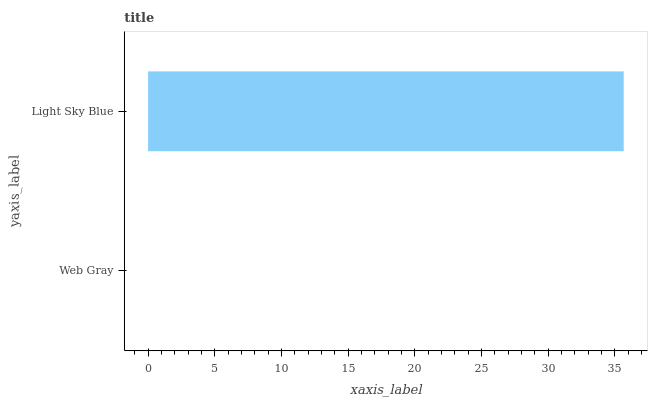Is Web Gray the minimum?
Answer yes or no. Yes. Is Light Sky Blue the maximum?
Answer yes or no. Yes. Is Light Sky Blue the minimum?
Answer yes or no. No. Is Light Sky Blue greater than Web Gray?
Answer yes or no. Yes. Is Web Gray less than Light Sky Blue?
Answer yes or no. Yes. Is Web Gray greater than Light Sky Blue?
Answer yes or no. No. Is Light Sky Blue less than Web Gray?
Answer yes or no. No. Is Light Sky Blue the high median?
Answer yes or no. Yes. Is Web Gray the low median?
Answer yes or no. Yes. Is Web Gray the high median?
Answer yes or no. No. Is Light Sky Blue the low median?
Answer yes or no. No. 